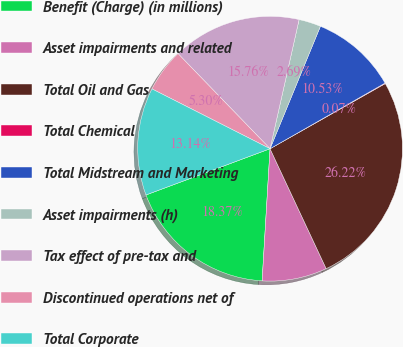Convert chart. <chart><loc_0><loc_0><loc_500><loc_500><pie_chart><fcel>Benefit (Charge) (in millions)<fcel>Asset impairments and related<fcel>Total Oil and Gas<fcel>Total Chemical<fcel>Total Midstream and Marketing<fcel>Asset impairments (h)<fcel>Tax effect of pre-tax and<fcel>Discontinued operations net of<fcel>Total Corporate<nl><fcel>18.37%<fcel>7.92%<fcel>26.22%<fcel>0.07%<fcel>10.53%<fcel>2.69%<fcel>15.76%<fcel>5.3%<fcel>13.14%<nl></chart> 